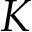<formula> <loc_0><loc_0><loc_500><loc_500>K</formula> 